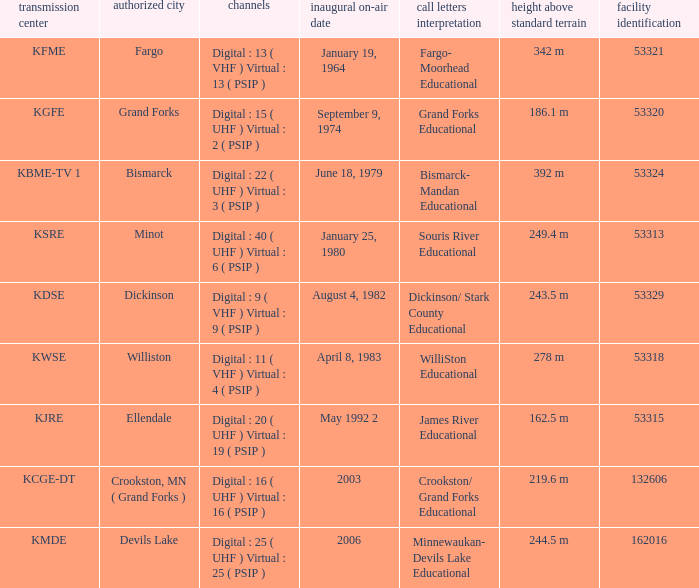What is the haat of devils lake 244.5 m. 